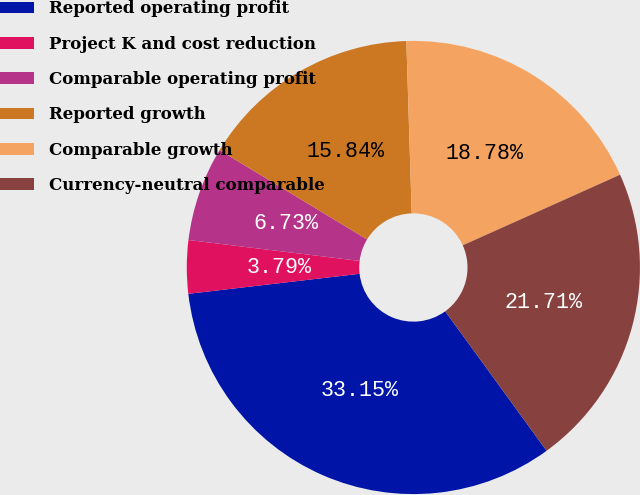<chart> <loc_0><loc_0><loc_500><loc_500><pie_chart><fcel>Reported operating profit<fcel>Project K and cost reduction<fcel>Comparable operating profit<fcel>Reported growth<fcel>Comparable growth<fcel>Currency-neutral comparable<nl><fcel>33.15%<fcel>3.79%<fcel>6.73%<fcel>15.84%<fcel>18.78%<fcel>21.71%<nl></chart> 